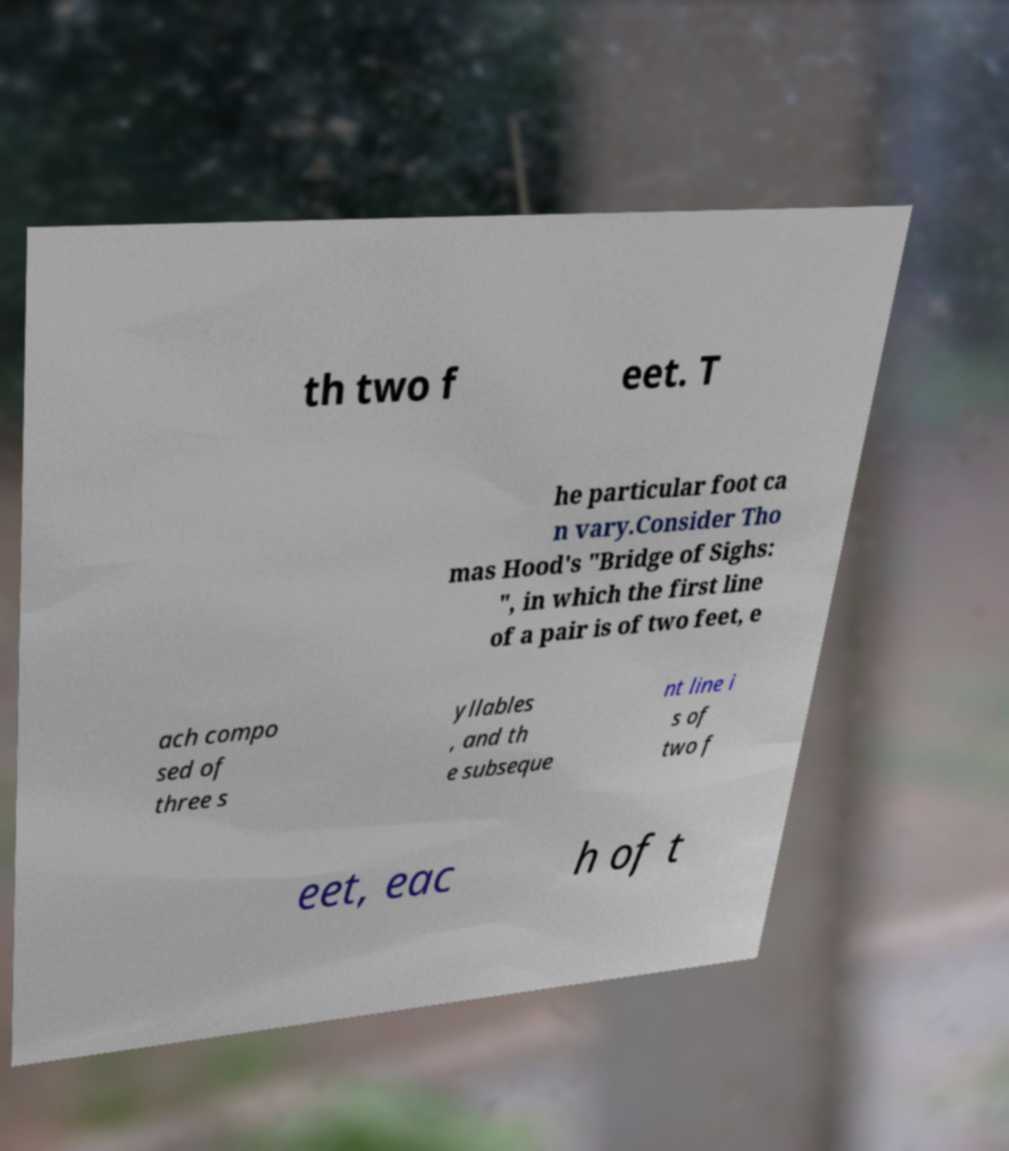Can you accurately transcribe the text from the provided image for me? th two f eet. T he particular foot ca n vary.Consider Tho mas Hood's "Bridge of Sighs: ", in which the first line of a pair is of two feet, e ach compo sed of three s yllables , and th e subseque nt line i s of two f eet, eac h of t 